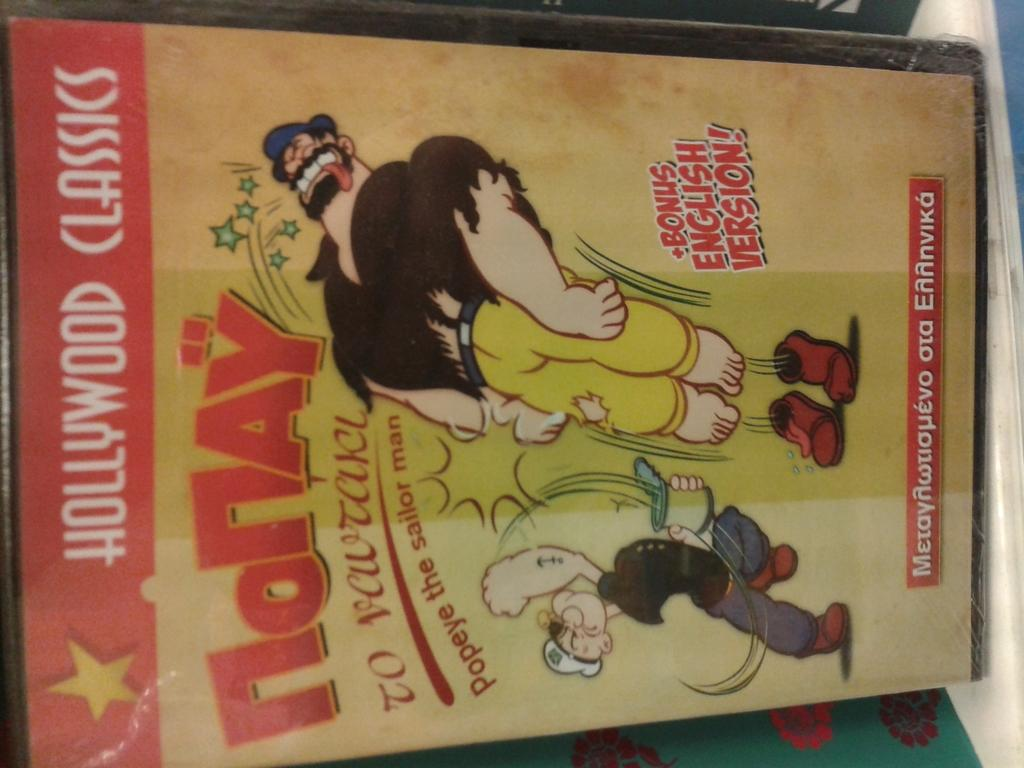<image>
Relay a brief, clear account of the picture shown. A Hollywood Classics Popeye comic shows Popeye punching someone. 